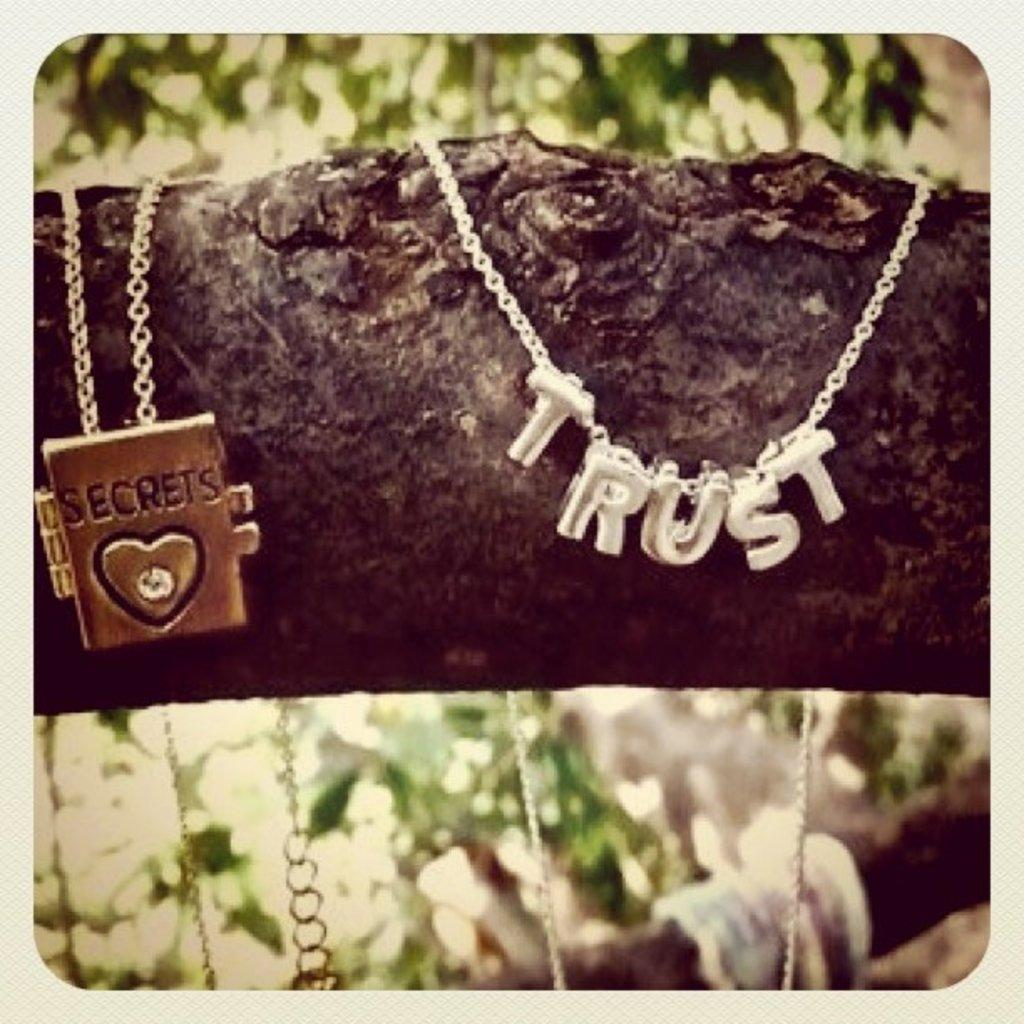<image>
Give a short and clear explanation of the subsequent image. A necklace with the word Trust sits next to another necklace of a diary that says secrets 